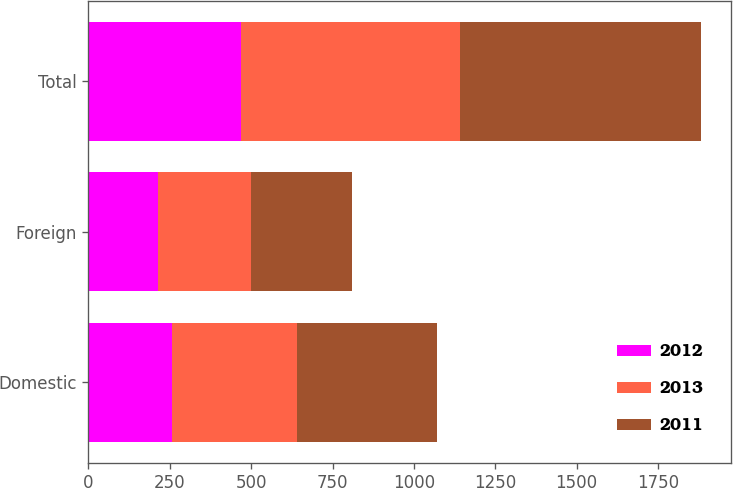Convert chart. <chart><loc_0><loc_0><loc_500><loc_500><stacked_bar_chart><ecel><fcel>Domestic<fcel>Foreign<fcel>Total<nl><fcel>2012<fcel>255.3<fcel>212.7<fcel>468<nl><fcel>2013<fcel>386.9<fcel>287.9<fcel>674.8<nl><fcel>2011<fcel>428.4<fcel>310<fcel>738.4<nl></chart> 